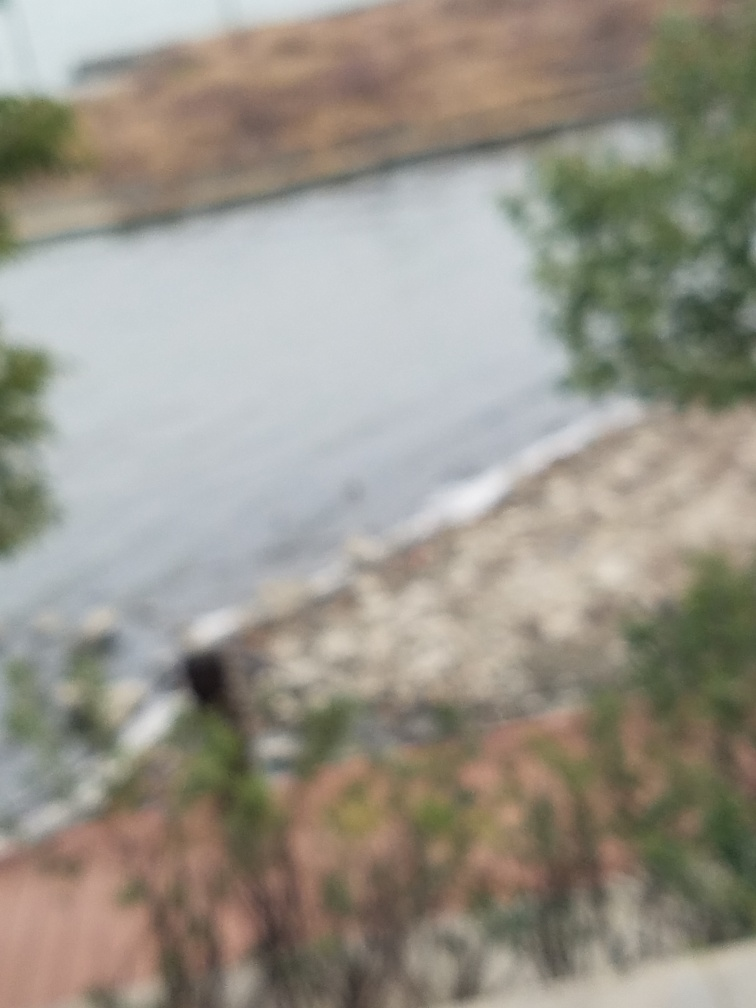What might be the reason for the image's blurriness? The blurriness could be due to several factors such as camera shake, incorrect focus settings, a dirty camera lens, or movement of the subject during the shot. Without more information, it's tough to pinpoint the exact cause. 